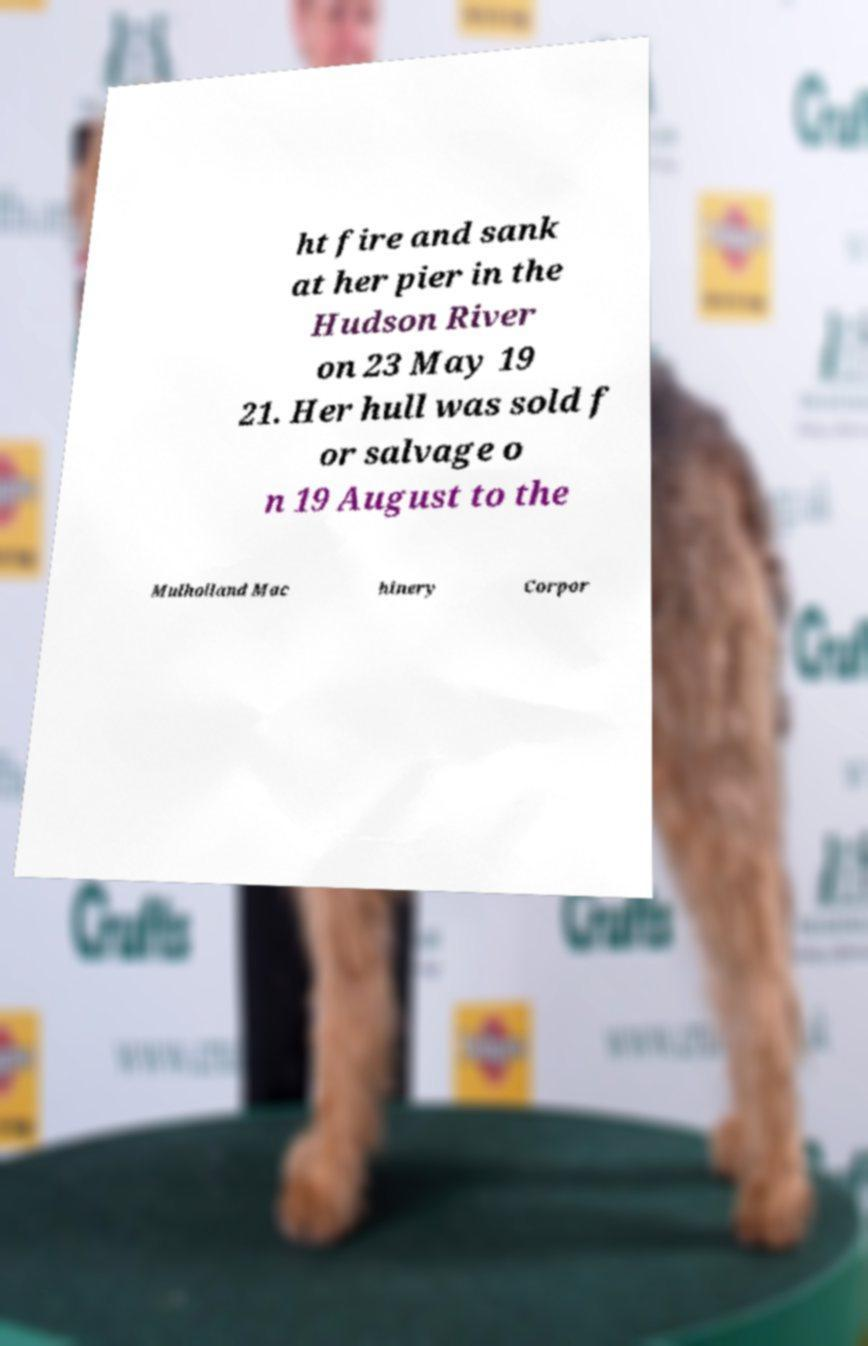I need the written content from this picture converted into text. Can you do that? ht fire and sank at her pier in the Hudson River on 23 May 19 21. Her hull was sold f or salvage o n 19 August to the Mulholland Mac hinery Corpor 